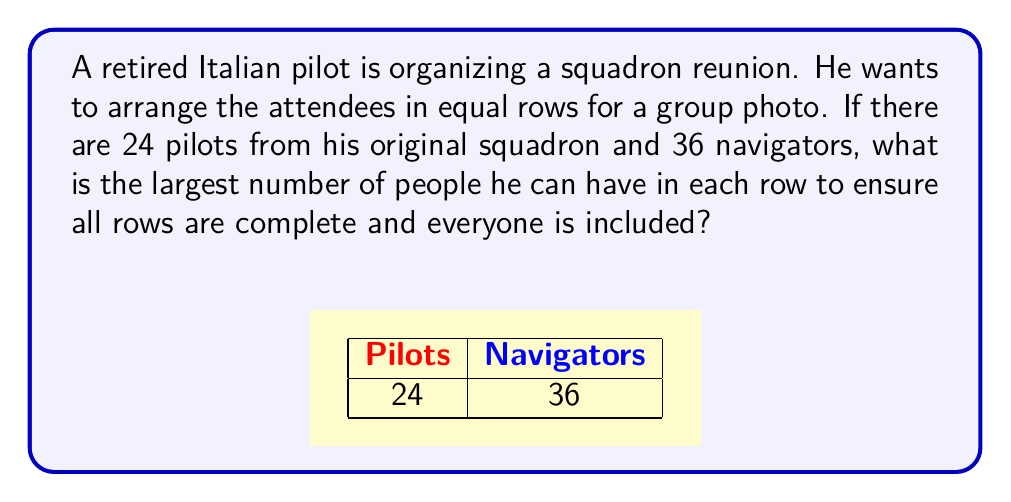Can you solve this math problem? To solve this problem, we need to find the least common multiple (LCM) of 24 and 36.

Step 1: Factor the numbers
$$24 = 2^3 \times 3$$
$$36 = 2^2 \times 3^2$$

Step 2: Identify the highest power of each prime factor
$2^3$ (from 24)
$3^2$ (from 36)

Step 3: Multiply these highest powers
$$LCM = 2^3 \times 3^2 = 8 \times 9 = 72$$

The LCM of 24 and 36 is 72. This means 72 is the smallest number that is divisible by both 24 and 36.

Step 4: Verify
$$72 \div 24 = 3$$ (whole number)
$$72 \div 36 = 2$$ (whole number)

Therefore, 72 people can be arranged in complete rows, with either 3 rows of 24 or 2 rows of 36.
Answer: 72 